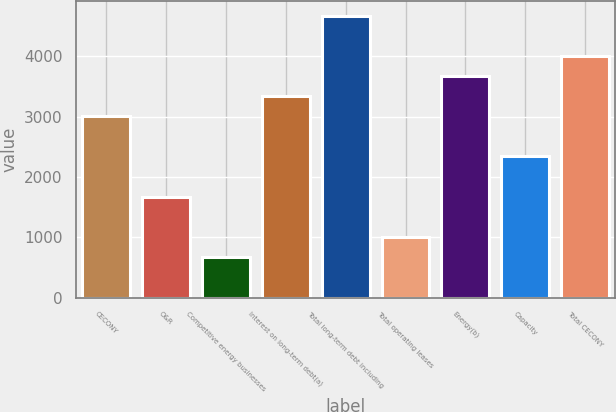<chart> <loc_0><loc_0><loc_500><loc_500><bar_chart><fcel>CECONY<fcel>O&R<fcel>Competitive energy businesses<fcel>Interest on long-term debt(a)<fcel>Total long-term debt including<fcel>Total operating leases<fcel>Energy(b)<fcel>Capacity<fcel>Total CECONY<nl><fcel>3008<fcel>1672<fcel>670<fcel>3342<fcel>4678<fcel>1004<fcel>3676<fcel>2340<fcel>4010<nl></chart> 